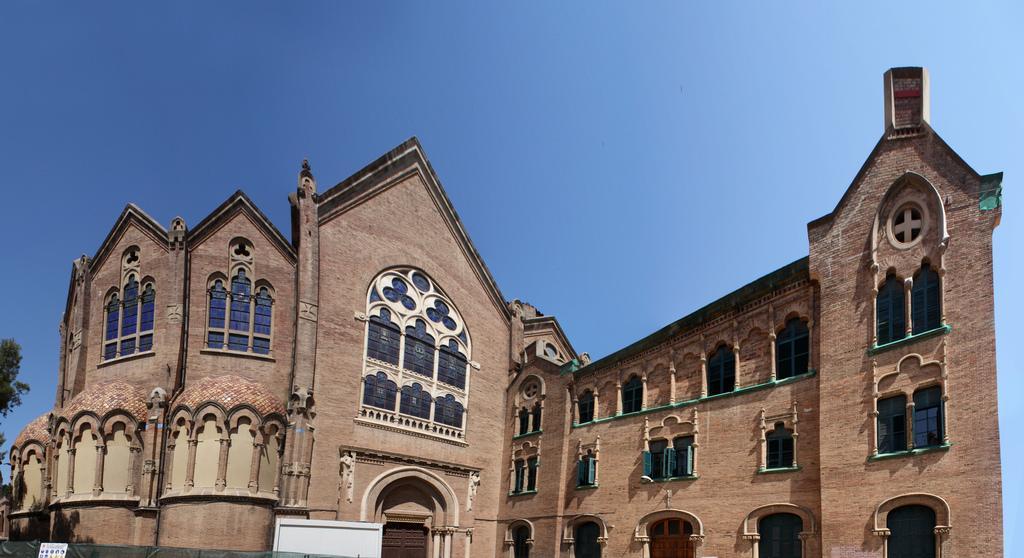How would you summarize this image in a sentence or two? In this picture we can see huge walls of a building above which the sky is blue. 